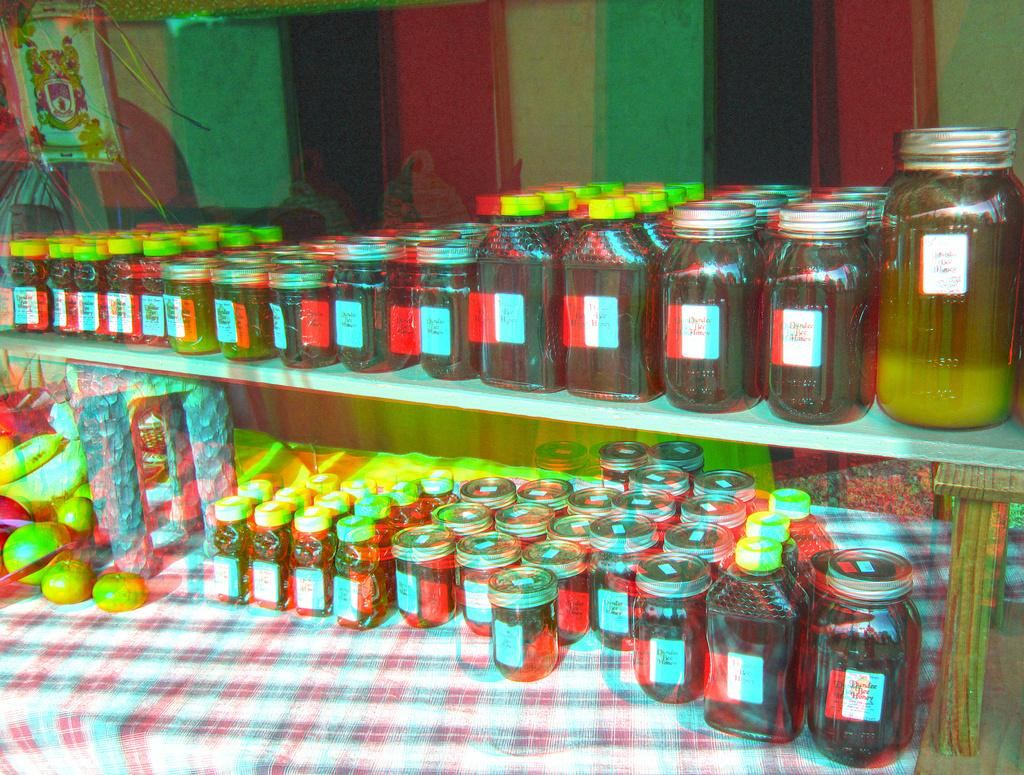What is the primary subject of the image? There are many jars in the image. What else can be seen in the image besides the jars? There are fruits, other objects, a cloth, tables, and a curtain in the background of the image. Can you describe the fruits in the image? The image contains fruits, but the specific types of fruits are not mentioned in the provided facts. What is the purpose of the cloth in the image? The purpose of the cloth in the image is not mentioned in the provided facts. What type of fear can be seen on the faces of the fairies in the image? There are no fairies present in the image, so it is not possible to determine if they are experiencing any fear. 